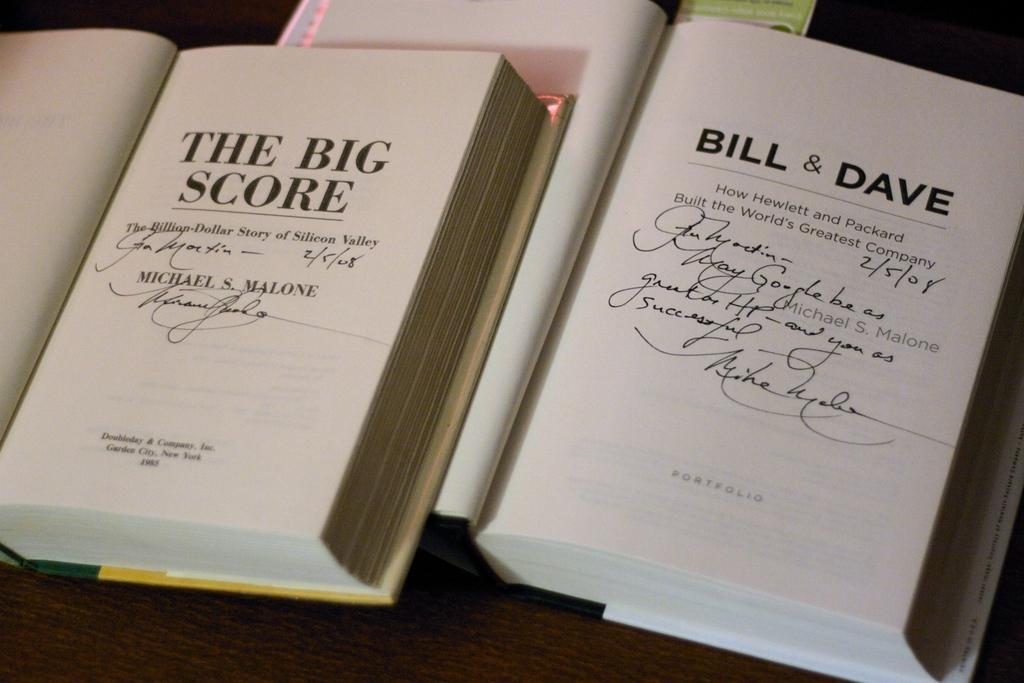<image>
Relay a brief, clear account of the picture shown. two books open to the title page of the big socre and Bill & Dave 